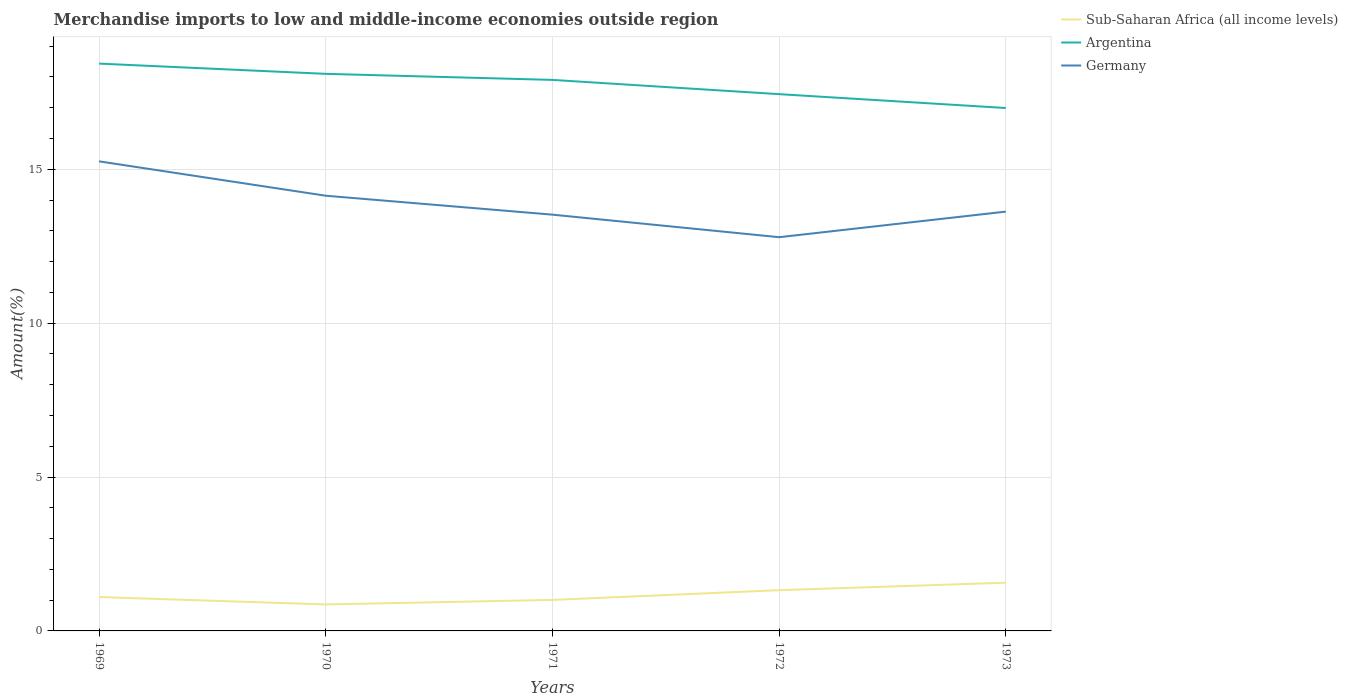Is the number of lines equal to the number of legend labels?
Ensure brevity in your answer.  Yes. Across all years, what is the maximum percentage of amount earned from merchandise imports in Germany?
Make the answer very short. 12.79. In which year was the percentage of amount earned from merchandise imports in Argentina maximum?
Give a very brief answer. 1973. What is the total percentage of amount earned from merchandise imports in Sub-Saharan Africa (all income levels) in the graph?
Ensure brevity in your answer.  0.24. What is the difference between the highest and the second highest percentage of amount earned from merchandise imports in Germany?
Offer a terse response. 2.46. Is the percentage of amount earned from merchandise imports in Argentina strictly greater than the percentage of amount earned from merchandise imports in Germany over the years?
Offer a very short reply. No. What is the difference between two consecutive major ticks on the Y-axis?
Provide a succinct answer. 5. Where does the legend appear in the graph?
Your answer should be compact. Top right. How many legend labels are there?
Your response must be concise. 3. How are the legend labels stacked?
Your answer should be compact. Vertical. What is the title of the graph?
Provide a short and direct response. Merchandise imports to low and middle-income economies outside region. What is the label or title of the X-axis?
Provide a short and direct response. Years. What is the label or title of the Y-axis?
Your answer should be very brief. Amount(%). What is the Amount(%) in Sub-Saharan Africa (all income levels) in 1969?
Provide a short and direct response. 1.1. What is the Amount(%) in Argentina in 1969?
Keep it short and to the point. 18.43. What is the Amount(%) of Germany in 1969?
Ensure brevity in your answer.  15.26. What is the Amount(%) of Sub-Saharan Africa (all income levels) in 1970?
Your answer should be compact. 0.86. What is the Amount(%) in Argentina in 1970?
Your answer should be very brief. 18.1. What is the Amount(%) in Germany in 1970?
Provide a short and direct response. 14.14. What is the Amount(%) of Sub-Saharan Africa (all income levels) in 1971?
Your answer should be very brief. 1.01. What is the Amount(%) in Argentina in 1971?
Give a very brief answer. 17.9. What is the Amount(%) in Germany in 1971?
Offer a terse response. 13.53. What is the Amount(%) in Sub-Saharan Africa (all income levels) in 1972?
Keep it short and to the point. 1.32. What is the Amount(%) in Argentina in 1972?
Provide a succinct answer. 17.44. What is the Amount(%) in Germany in 1972?
Make the answer very short. 12.79. What is the Amount(%) in Sub-Saharan Africa (all income levels) in 1973?
Make the answer very short. 1.57. What is the Amount(%) of Argentina in 1973?
Keep it short and to the point. 16.99. What is the Amount(%) of Germany in 1973?
Give a very brief answer. 13.62. Across all years, what is the maximum Amount(%) of Sub-Saharan Africa (all income levels)?
Give a very brief answer. 1.57. Across all years, what is the maximum Amount(%) in Argentina?
Provide a succinct answer. 18.43. Across all years, what is the maximum Amount(%) of Germany?
Provide a short and direct response. 15.26. Across all years, what is the minimum Amount(%) of Sub-Saharan Africa (all income levels)?
Offer a terse response. 0.86. Across all years, what is the minimum Amount(%) in Argentina?
Give a very brief answer. 16.99. Across all years, what is the minimum Amount(%) in Germany?
Give a very brief answer. 12.79. What is the total Amount(%) of Sub-Saharan Africa (all income levels) in the graph?
Give a very brief answer. 5.86. What is the total Amount(%) of Argentina in the graph?
Provide a short and direct response. 88.87. What is the total Amount(%) in Germany in the graph?
Your answer should be very brief. 69.34. What is the difference between the Amount(%) in Sub-Saharan Africa (all income levels) in 1969 and that in 1970?
Offer a terse response. 0.24. What is the difference between the Amount(%) in Argentina in 1969 and that in 1970?
Keep it short and to the point. 0.33. What is the difference between the Amount(%) of Germany in 1969 and that in 1970?
Provide a succinct answer. 1.12. What is the difference between the Amount(%) in Sub-Saharan Africa (all income levels) in 1969 and that in 1971?
Ensure brevity in your answer.  0.09. What is the difference between the Amount(%) in Argentina in 1969 and that in 1971?
Provide a succinct answer. 0.53. What is the difference between the Amount(%) in Germany in 1969 and that in 1971?
Make the answer very short. 1.73. What is the difference between the Amount(%) of Sub-Saharan Africa (all income levels) in 1969 and that in 1972?
Keep it short and to the point. -0.22. What is the difference between the Amount(%) of Germany in 1969 and that in 1972?
Provide a short and direct response. 2.46. What is the difference between the Amount(%) in Sub-Saharan Africa (all income levels) in 1969 and that in 1973?
Give a very brief answer. -0.47. What is the difference between the Amount(%) of Argentina in 1969 and that in 1973?
Your answer should be very brief. 1.44. What is the difference between the Amount(%) in Germany in 1969 and that in 1973?
Your answer should be compact. 1.63. What is the difference between the Amount(%) of Sub-Saharan Africa (all income levels) in 1970 and that in 1971?
Your answer should be very brief. -0.15. What is the difference between the Amount(%) in Argentina in 1970 and that in 1971?
Give a very brief answer. 0.2. What is the difference between the Amount(%) of Germany in 1970 and that in 1971?
Offer a very short reply. 0.61. What is the difference between the Amount(%) of Sub-Saharan Africa (all income levels) in 1970 and that in 1972?
Your response must be concise. -0.46. What is the difference between the Amount(%) of Argentina in 1970 and that in 1972?
Make the answer very short. 0.66. What is the difference between the Amount(%) in Germany in 1970 and that in 1972?
Your answer should be compact. 1.35. What is the difference between the Amount(%) of Sub-Saharan Africa (all income levels) in 1970 and that in 1973?
Your answer should be compact. -0.71. What is the difference between the Amount(%) of Argentina in 1970 and that in 1973?
Keep it short and to the point. 1.11. What is the difference between the Amount(%) in Germany in 1970 and that in 1973?
Keep it short and to the point. 0.52. What is the difference between the Amount(%) in Sub-Saharan Africa (all income levels) in 1971 and that in 1972?
Offer a terse response. -0.32. What is the difference between the Amount(%) of Argentina in 1971 and that in 1972?
Your answer should be very brief. 0.46. What is the difference between the Amount(%) of Germany in 1971 and that in 1972?
Your answer should be compact. 0.73. What is the difference between the Amount(%) in Sub-Saharan Africa (all income levels) in 1971 and that in 1973?
Your response must be concise. -0.56. What is the difference between the Amount(%) in Argentina in 1971 and that in 1973?
Ensure brevity in your answer.  0.91. What is the difference between the Amount(%) in Germany in 1971 and that in 1973?
Your answer should be compact. -0.1. What is the difference between the Amount(%) in Sub-Saharan Africa (all income levels) in 1972 and that in 1973?
Keep it short and to the point. -0.24. What is the difference between the Amount(%) in Argentina in 1972 and that in 1973?
Offer a terse response. 0.45. What is the difference between the Amount(%) of Germany in 1972 and that in 1973?
Provide a succinct answer. -0.83. What is the difference between the Amount(%) in Sub-Saharan Africa (all income levels) in 1969 and the Amount(%) in Argentina in 1970?
Give a very brief answer. -17. What is the difference between the Amount(%) in Sub-Saharan Africa (all income levels) in 1969 and the Amount(%) in Germany in 1970?
Offer a terse response. -13.04. What is the difference between the Amount(%) of Argentina in 1969 and the Amount(%) of Germany in 1970?
Make the answer very short. 4.29. What is the difference between the Amount(%) of Sub-Saharan Africa (all income levels) in 1969 and the Amount(%) of Argentina in 1971?
Offer a terse response. -16.8. What is the difference between the Amount(%) in Sub-Saharan Africa (all income levels) in 1969 and the Amount(%) in Germany in 1971?
Ensure brevity in your answer.  -12.43. What is the difference between the Amount(%) in Argentina in 1969 and the Amount(%) in Germany in 1971?
Give a very brief answer. 4.91. What is the difference between the Amount(%) in Sub-Saharan Africa (all income levels) in 1969 and the Amount(%) in Argentina in 1972?
Ensure brevity in your answer.  -16.34. What is the difference between the Amount(%) of Sub-Saharan Africa (all income levels) in 1969 and the Amount(%) of Germany in 1972?
Offer a terse response. -11.69. What is the difference between the Amount(%) in Argentina in 1969 and the Amount(%) in Germany in 1972?
Give a very brief answer. 5.64. What is the difference between the Amount(%) in Sub-Saharan Africa (all income levels) in 1969 and the Amount(%) in Argentina in 1973?
Keep it short and to the point. -15.89. What is the difference between the Amount(%) in Sub-Saharan Africa (all income levels) in 1969 and the Amount(%) in Germany in 1973?
Keep it short and to the point. -12.52. What is the difference between the Amount(%) in Argentina in 1969 and the Amount(%) in Germany in 1973?
Make the answer very short. 4.81. What is the difference between the Amount(%) of Sub-Saharan Africa (all income levels) in 1970 and the Amount(%) of Argentina in 1971?
Offer a terse response. -17.04. What is the difference between the Amount(%) in Sub-Saharan Africa (all income levels) in 1970 and the Amount(%) in Germany in 1971?
Offer a very short reply. -12.67. What is the difference between the Amount(%) in Argentina in 1970 and the Amount(%) in Germany in 1971?
Provide a succinct answer. 4.58. What is the difference between the Amount(%) in Sub-Saharan Africa (all income levels) in 1970 and the Amount(%) in Argentina in 1972?
Ensure brevity in your answer.  -16.58. What is the difference between the Amount(%) of Sub-Saharan Africa (all income levels) in 1970 and the Amount(%) of Germany in 1972?
Offer a terse response. -11.93. What is the difference between the Amount(%) of Argentina in 1970 and the Amount(%) of Germany in 1972?
Give a very brief answer. 5.31. What is the difference between the Amount(%) in Sub-Saharan Africa (all income levels) in 1970 and the Amount(%) in Argentina in 1973?
Offer a very short reply. -16.13. What is the difference between the Amount(%) in Sub-Saharan Africa (all income levels) in 1970 and the Amount(%) in Germany in 1973?
Provide a succinct answer. -12.76. What is the difference between the Amount(%) of Argentina in 1970 and the Amount(%) of Germany in 1973?
Provide a short and direct response. 4.48. What is the difference between the Amount(%) in Sub-Saharan Africa (all income levels) in 1971 and the Amount(%) in Argentina in 1972?
Provide a short and direct response. -16.43. What is the difference between the Amount(%) in Sub-Saharan Africa (all income levels) in 1971 and the Amount(%) in Germany in 1972?
Your answer should be very brief. -11.79. What is the difference between the Amount(%) in Argentina in 1971 and the Amount(%) in Germany in 1972?
Your answer should be compact. 5.11. What is the difference between the Amount(%) of Sub-Saharan Africa (all income levels) in 1971 and the Amount(%) of Argentina in 1973?
Your answer should be compact. -15.98. What is the difference between the Amount(%) of Sub-Saharan Africa (all income levels) in 1971 and the Amount(%) of Germany in 1973?
Your answer should be compact. -12.62. What is the difference between the Amount(%) of Argentina in 1971 and the Amount(%) of Germany in 1973?
Your response must be concise. 4.28. What is the difference between the Amount(%) in Sub-Saharan Africa (all income levels) in 1972 and the Amount(%) in Argentina in 1973?
Provide a succinct answer. -15.67. What is the difference between the Amount(%) in Sub-Saharan Africa (all income levels) in 1972 and the Amount(%) in Germany in 1973?
Offer a terse response. -12.3. What is the difference between the Amount(%) in Argentina in 1972 and the Amount(%) in Germany in 1973?
Keep it short and to the point. 3.82. What is the average Amount(%) of Sub-Saharan Africa (all income levels) per year?
Give a very brief answer. 1.17. What is the average Amount(%) of Argentina per year?
Your response must be concise. 17.77. What is the average Amount(%) of Germany per year?
Keep it short and to the point. 13.87. In the year 1969, what is the difference between the Amount(%) in Sub-Saharan Africa (all income levels) and Amount(%) in Argentina?
Your response must be concise. -17.33. In the year 1969, what is the difference between the Amount(%) in Sub-Saharan Africa (all income levels) and Amount(%) in Germany?
Provide a short and direct response. -14.16. In the year 1969, what is the difference between the Amount(%) of Argentina and Amount(%) of Germany?
Your answer should be compact. 3.18. In the year 1970, what is the difference between the Amount(%) in Sub-Saharan Africa (all income levels) and Amount(%) in Argentina?
Offer a very short reply. -17.24. In the year 1970, what is the difference between the Amount(%) in Sub-Saharan Africa (all income levels) and Amount(%) in Germany?
Your answer should be very brief. -13.28. In the year 1970, what is the difference between the Amount(%) of Argentina and Amount(%) of Germany?
Provide a succinct answer. 3.96. In the year 1971, what is the difference between the Amount(%) in Sub-Saharan Africa (all income levels) and Amount(%) in Argentina?
Give a very brief answer. -16.9. In the year 1971, what is the difference between the Amount(%) in Sub-Saharan Africa (all income levels) and Amount(%) in Germany?
Provide a succinct answer. -12.52. In the year 1971, what is the difference between the Amount(%) in Argentina and Amount(%) in Germany?
Your response must be concise. 4.38. In the year 1972, what is the difference between the Amount(%) in Sub-Saharan Africa (all income levels) and Amount(%) in Argentina?
Your answer should be compact. -16.12. In the year 1972, what is the difference between the Amount(%) of Sub-Saharan Africa (all income levels) and Amount(%) of Germany?
Offer a very short reply. -11.47. In the year 1972, what is the difference between the Amount(%) of Argentina and Amount(%) of Germany?
Ensure brevity in your answer.  4.65. In the year 1973, what is the difference between the Amount(%) in Sub-Saharan Africa (all income levels) and Amount(%) in Argentina?
Offer a terse response. -15.42. In the year 1973, what is the difference between the Amount(%) of Sub-Saharan Africa (all income levels) and Amount(%) of Germany?
Give a very brief answer. -12.06. In the year 1973, what is the difference between the Amount(%) of Argentina and Amount(%) of Germany?
Your answer should be very brief. 3.37. What is the ratio of the Amount(%) in Sub-Saharan Africa (all income levels) in 1969 to that in 1970?
Offer a terse response. 1.28. What is the ratio of the Amount(%) of Argentina in 1969 to that in 1970?
Offer a terse response. 1.02. What is the ratio of the Amount(%) in Germany in 1969 to that in 1970?
Offer a terse response. 1.08. What is the ratio of the Amount(%) in Sub-Saharan Africa (all income levels) in 1969 to that in 1971?
Your response must be concise. 1.09. What is the ratio of the Amount(%) of Argentina in 1969 to that in 1971?
Your answer should be compact. 1.03. What is the ratio of the Amount(%) of Germany in 1969 to that in 1971?
Your answer should be very brief. 1.13. What is the ratio of the Amount(%) in Sub-Saharan Africa (all income levels) in 1969 to that in 1972?
Ensure brevity in your answer.  0.83. What is the ratio of the Amount(%) of Argentina in 1969 to that in 1972?
Your answer should be very brief. 1.06. What is the ratio of the Amount(%) of Germany in 1969 to that in 1972?
Provide a succinct answer. 1.19. What is the ratio of the Amount(%) of Sub-Saharan Africa (all income levels) in 1969 to that in 1973?
Your response must be concise. 0.7. What is the ratio of the Amount(%) of Argentina in 1969 to that in 1973?
Provide a short and direct response. 1.08. What is the ratio of the Amount(%) in Germany in 1969 to that in 1973?
Give a very brief answer. 1.12. What is the ratio of the Amount(%) of Sub-Saharan Africa (all income levels) in 1970 to that in 1971?
Your answer should be very brief. 0.85. What is the ratio of the Amount(%) of Argentina in 1970 to that in 1971?
Offer a terse response. 1.01. What is the ratio of the Amount(%) in Germany in 1970 to that in 1971?
Your answer should be compact. 1.05. What is the ratio of the Amount(%) in Sub-Saharan Africa (all income levels) in 1970 to that in 1972?
Ensure brevity in your answer.  0.65. What is the ratio of the Amount(%) of Argentina in 1970 to that in 1972?
Make the answer very short. 1.04. What is the ratio of the Amount(%) of Germany in 1970 to that in 1972?
Ensure brevity in your answer.  1.11. What is the ratio of the Amount(%) in Sub-Saharan Africa (all income levels) in 1970 to that in 1973?
Give a very brief answer. 0.55. What is the ratio of the Amount(%) in Argentina in 1970 to that in 1973?
Ensure brevity in your answer.  1.07. What is the ratio of the Amount(%) in Germany in 1970 to that in 1973?
Make the answer very short. 1.04. What is the ratio of the Amount(%) of Sub-Saharan Africa (all income levels) in 1971 to that in 1972?
Make the answer very short. 0.76. What is the ratio of the Amount(%) of Argentina in 1971 to that in 1972?
Provide a short and direct response. 1.03. What is the ratio of the Amount(%) in Germany in 1971 to that in 1972?
Make the answer very short. 1.06. What is the ratio of the Amount(%) of Sub-Saharan Africa (all income levels) in 1971 to that in 1973?
Provide a short and direct response. 0.64. What is the ratio of the Amount(%) in Argentina in 1971 to that in 1973?
Your response must be concise. 1.05. What is the ratio of the Amount(%) in Sub-Saharan Africa (all income levels) in 1972 to that in 1973?
Your response must be concise. 0.85. What is the ratio of the Amount(%) of Argentina in 1972 to that in 1973?
Your response must be concise. 1.03. What is the ratio of the Amount(%) of Germany in 1972 to that in 1973?
Your answer should be compact. 0.94. What is the difference between the highest and the second highest Amount(%) of Sub-Saharan Africa (all income levels)?
Ensure brevity in your answer.  0.24. What is the difference between the highest and the second highest Amount(%) of Argentina?
Your response must be concise. 0.33. What is the difference between the highest and the second highest Amount(%) of Germany?
Your answer should be very brief. 1.12. What is the difference between the highest and the lowest Amount(%) of Sub-Saharan Africa (all income levels)?
Provide a succinct answer. 0.71. What is the difference between the highest and the lowest Amount(%) of Argentina?
Keep it short and to the point. 1.44. What is the difference between the highest and the lowest Amount(%) of Germany?
Give a very brief answer. 2.46. 